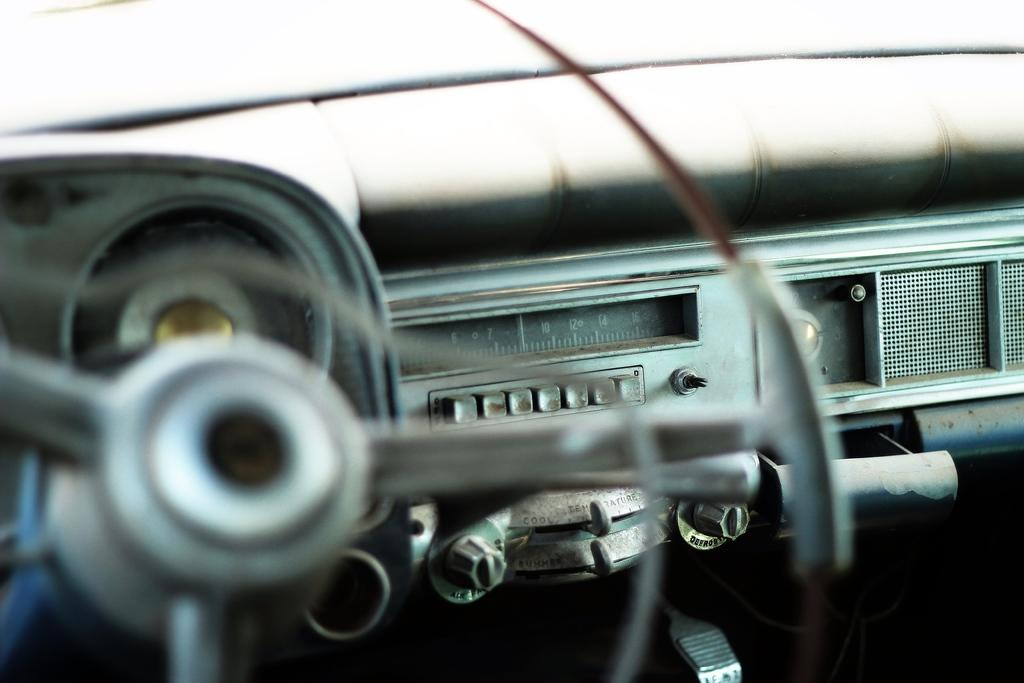What is the primary object in the image? There is a steering wheel in the image. What instrument is used to measure speed in the image? There is a speedometer in the image. What type of controls are present in the image? There are buttons in the image. Can you describe any other objects in the image? There are other unspecified objects in the image. What type of plantation can be seen in the background of the image? There is no plantation visible in the image; it primarily features a steering wheel, speedometer, buttons, and other unspecified objects. 